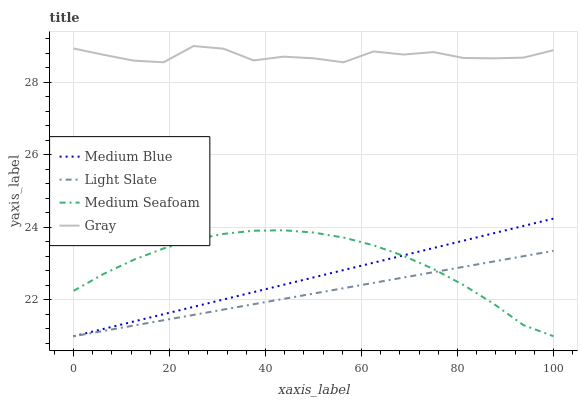Does Light Slate have the minimum area under the curve?
Answer yes or no. Yes. Does Gray have the maximum area under the curve?
Answer yes or no. Yes. Does Medium Blue have the minimum area under the curve?
Answer yes or no. No. Does Medium Blue have the maximum area under the curve?
Answer yes or no. No. Is Medium Blue the smoothest?
Answer yes or no. Yes. Is Gray the roughest?
Answer yes or no. Yes. Is Gray the smoothest?
Answer yes or no. No. Is Medium Blue the roughest?
Answer yes or no. No. Does Gray have the lowest value?
Answer yes or no. No. Does Gray have the highest value?
Answer yes or no. Yes. Does Medium Blue have the highest value?
Answer yes or no. No. Is Light Slate less than Gray?
Answer yes or no. Yes. Is Gray greater than Medium Seafoam?
Answer yes or no. Yes. Does Medium Seafoam intersect Medium Blue?
Answer yes or no. Yes. Is Medium Seafoam less than Medium Blue?
Answer yes or no. No. Is Medium Seafoam greater than Medium Blue?
Answer yes or no. No. Does Light Slate intersect Gray?
Answer yes or no. No. 